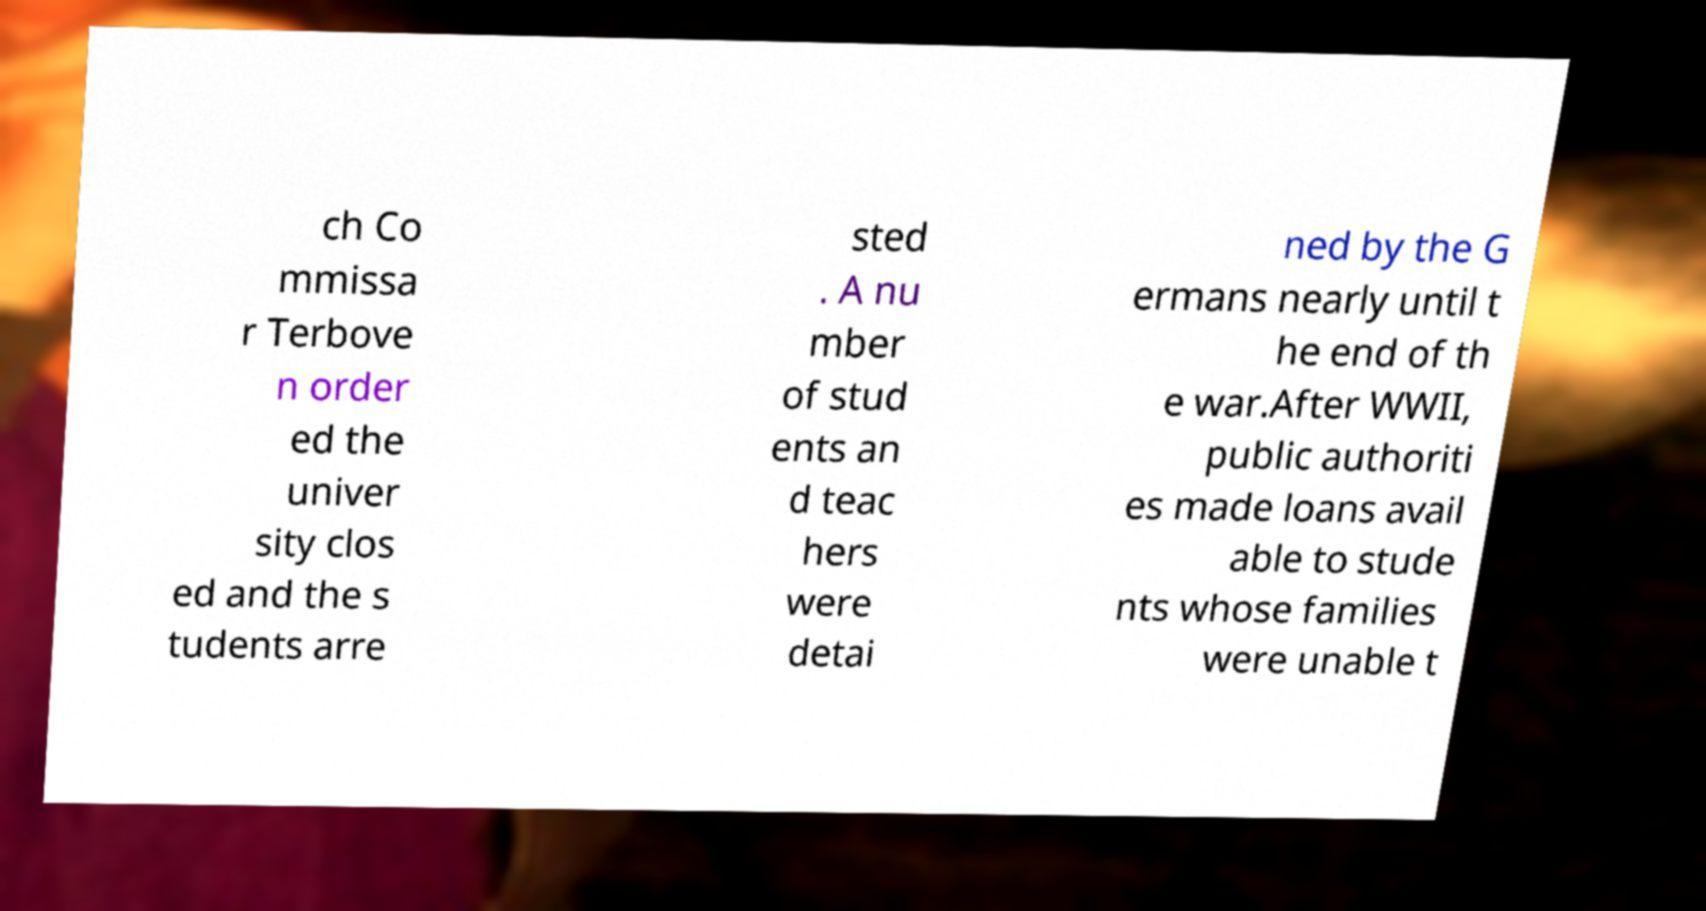What messages or text are displayed in this image? I need them in a readable, typed format. ch Co mmissa r Terbove n order ed the univer sity clos ed and the s tudents arre sted . A nu mber of stud ents an d teac hers were detai ned by the G ermans nearly until t he end of th e war.After WWII, public authoriti es made loans avail able to stude nts whose families were unable t 